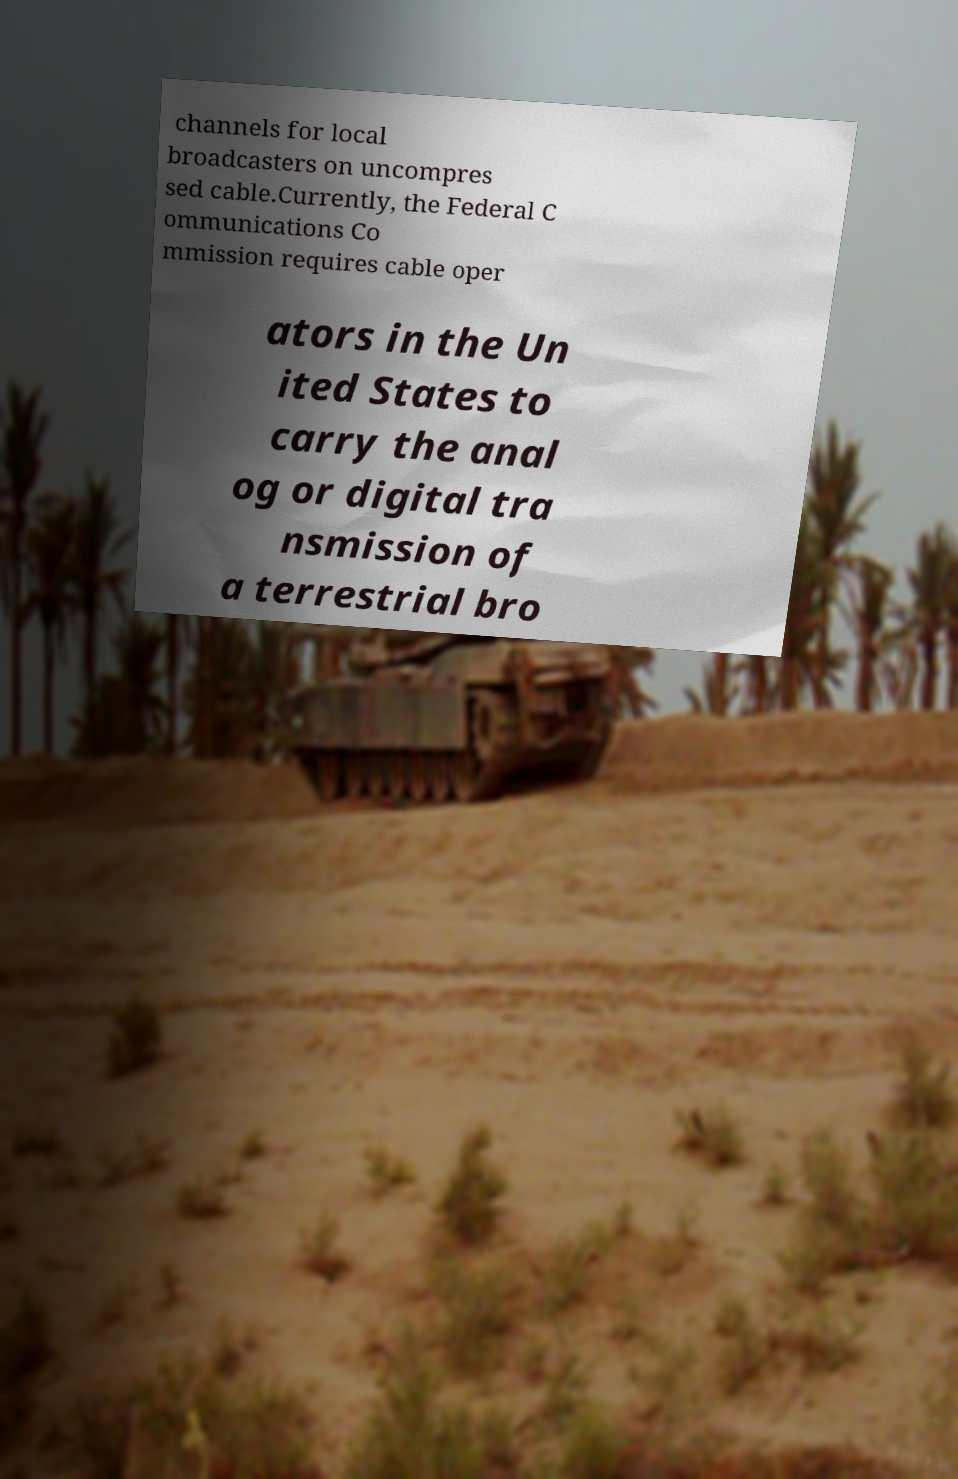For documentation purposes, I need the text within this image transcribed. Could you provide that? channels for local broadcasters on uncompres sed cable.Currently, the Federal C ommunications Co mmission requires cable oper ators in the Un ited States to carry the anal og or digital tra nsmission of a terrestrial bro 